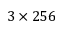Convert formula to latex. <formula><loc_0><loc_0><loc_500><loc_500>3 \times 2 5 6</formula> 